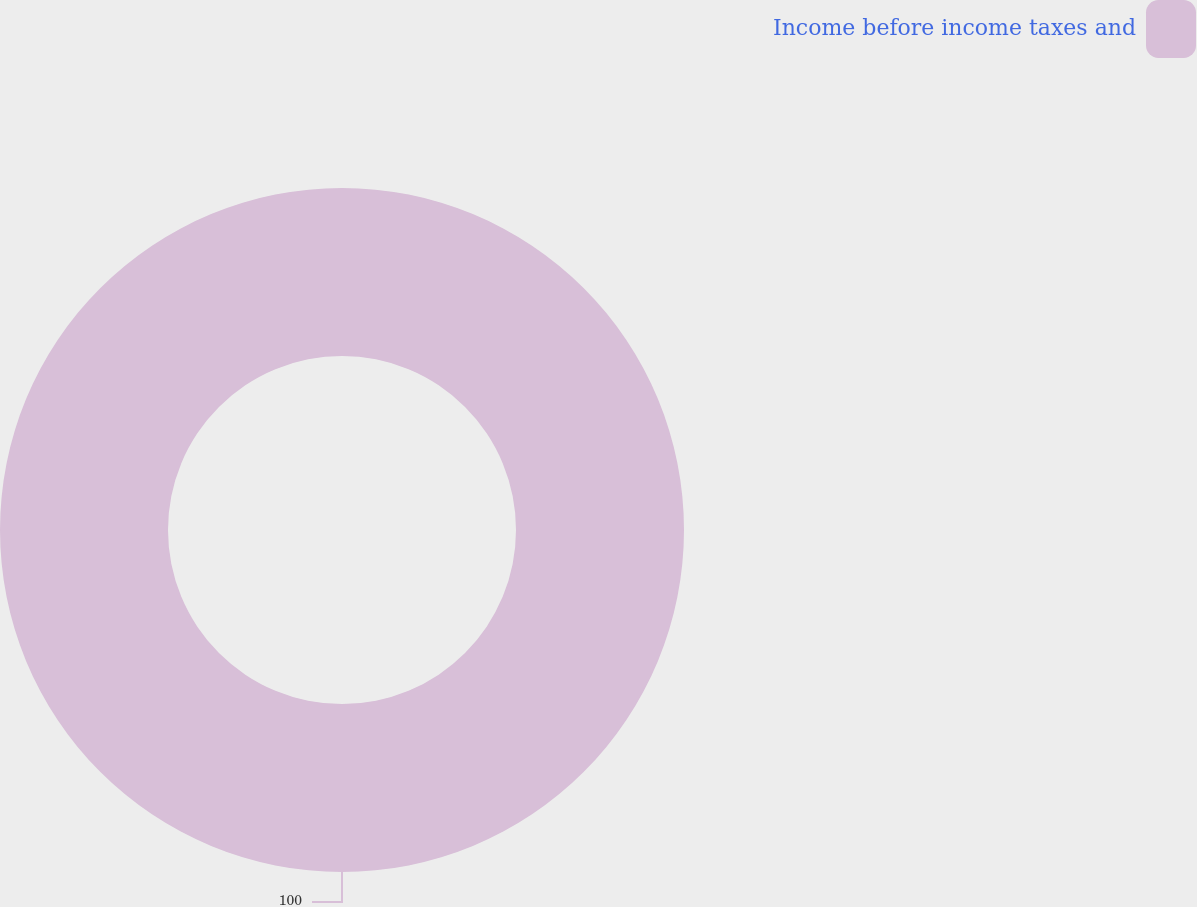Convert chart. <chart><loc_0><loc_0><loc_500><loc_500><pie_chart><fcel>Income before income taxes and<nl><fcel>100.0%<nl></chart> 